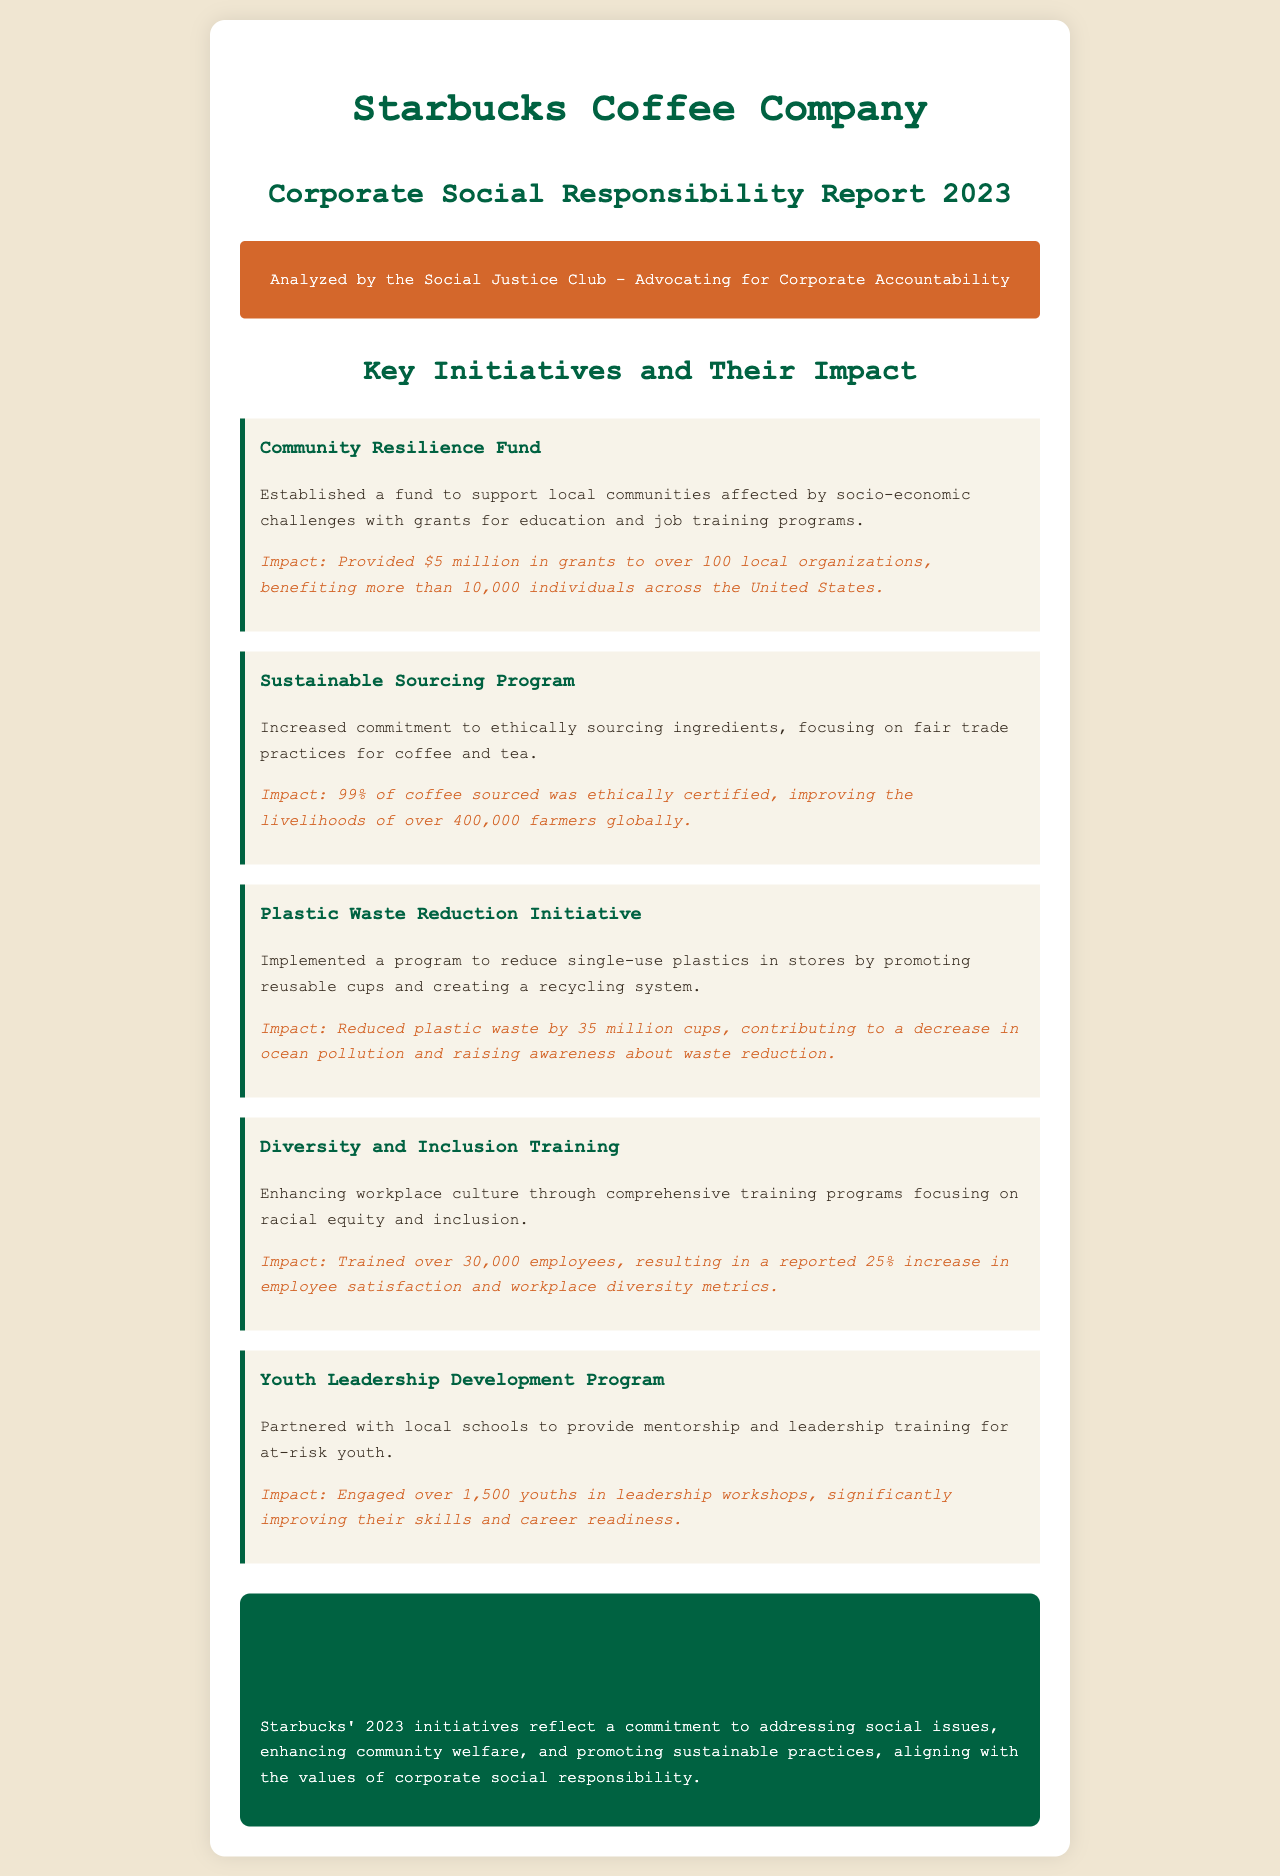What is the name of the report? The report is titled "Corporate Social Responsibility Report 2023 - Starbucks."
Answer: Corporate Social Responsibility Report 2023 - Starbucks How much funding was provided through the Community Resilience Fund? The funding amount is stated in the initiative description where it says $5 million in grants were provided.
Answer: $5 million What percentage of coffee sourced was ethically certified? The document indicates that 99% of the coffee sourced was ethically certified.
Answer: 99% How many employees were trained in Diversity and Inclusion Training? The number of employees trained is explicitly mentioned as over 30,000 in the initiative.
Answer: over 30,000 What was the impact of the Plastic Waste Reduction Initiative? The document explains the impact as a reduction of 35 million cups of plastic waste.
Answer: 35 million cups How many local organizations received support from the Community Resilience Fund? According to the report, the fund benefited over 100 local organizations.
Answer: over 100 What main focus did the Sustainable Sourcing Program have? The focus of the program is described as ethically sourcing ingredients, particularly emphasizing fair trade practices.
Answer: ethically sourcing ingredients What ultimate goal does the Youth Leadership Development Program aim to achieve? The aim of the program is to improve skills and career readiness for at-risk youth.
Answer: improve skills and career readiness What noted increase was reported in employee satisfaction due to training? The document states there was a reported 25% increase in employee satisfaction.
Answer: 25% 